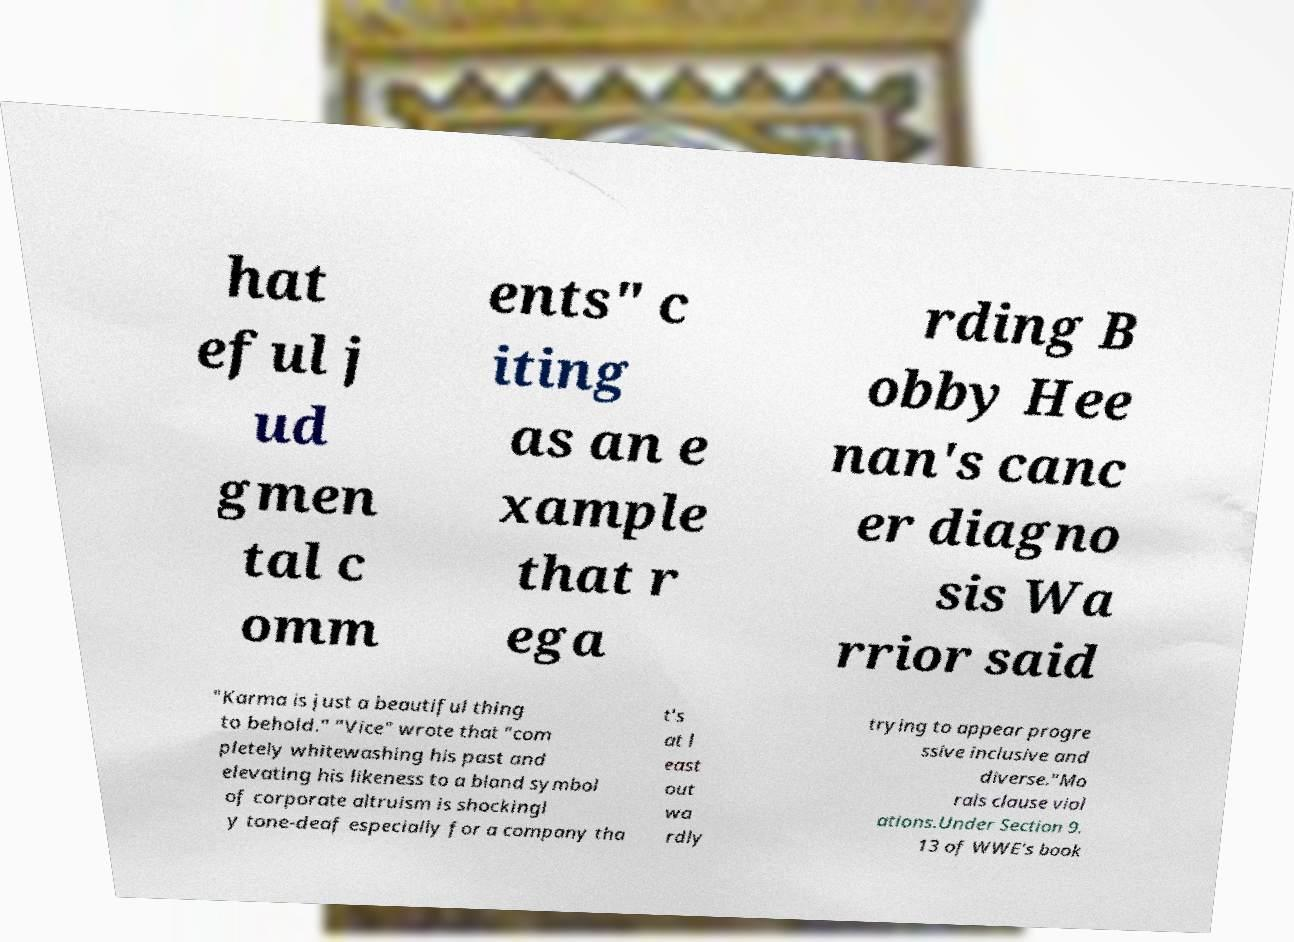What messages or text are displayed in this image? I need them in a readable, typed format. hat eful j ud gmen tal c omm ents" c iting as an e xample that r ega rding B obby Hee nan's canc er diagno sis Wa rrior said "Karma is just a beautiful thing to behold." "Vice" wrote that "com pletely whitewashing his past and elevating his likeness to a bland symbol of corporate altruism is shockingl y tone-deaf especially for a company tha t's at l east out wa rdly trying to appear progre ssive inclusive and diverse."Mo rals clause viol ations.Under Section 9. 13 of WWE's book 